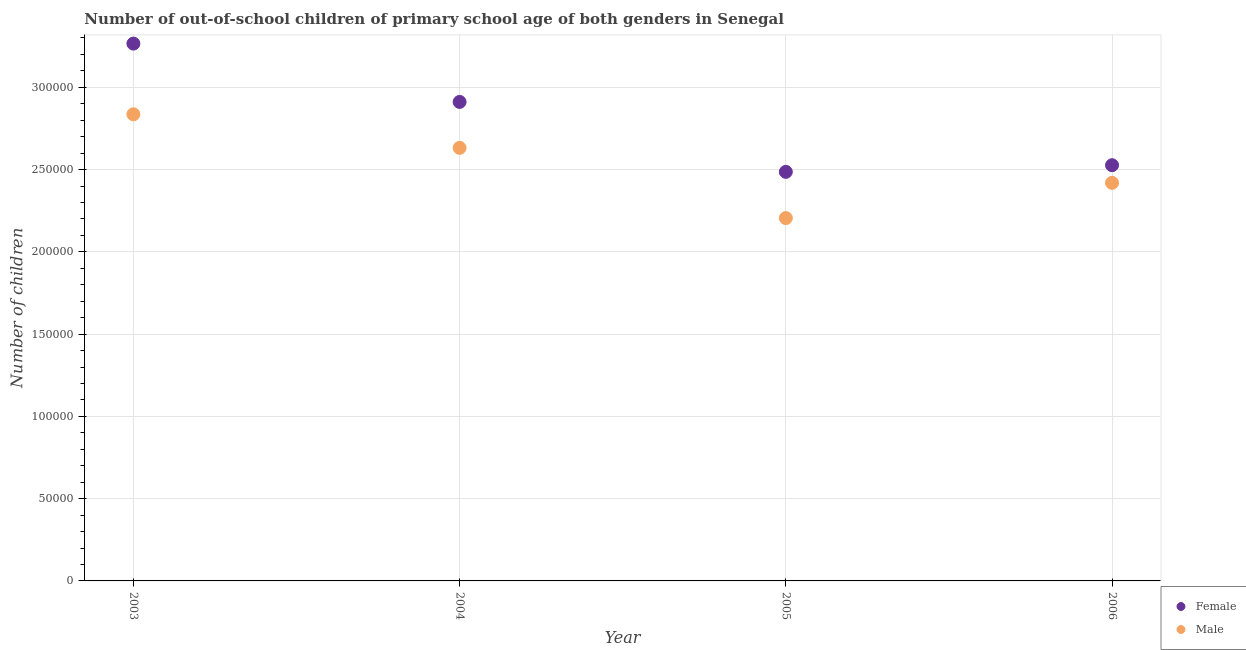What is the number of female out-of-school students in 2006?
Keep it short and to the point. 2.53e+05. Across all years, what is the maximum number of male out-of-school students?
Ensure brevity in your answer.  2.84e+05. Across all years, what is the minimum number of male out-of-school students?
Keep it short and to the point. 2.21e+05. In which year was the number of male out-of-school students minimum?
Your answer should be compact. 2005. What is the total number of female out-of-school students in the graph?
Your answer should be very brief. 1.12e+06. What is the difference between the number of male out-of-school students in 2003 and that in 2005?
Ensure brevity in your answer.  6.31e+04. What is the difference between the number of male out-of-school students in 2006 and the number of female out-of-school students in 2004?
Give a very brief answer. -4.92e+04. What is the average number of male out-of-school students per year?
Offer a terse response. 2.52e+05. In the year 2006, what is the difference between the number of female out-of-school students and number of male out-of-school students?
Your answer should be very brief. 1.07e+04. What is the ratio of the number of female out-of-school students in 2003 to that in 2005?
Give a very brief answer. 1.31. Is the number of male out-of-school students in 2005 less than that in 2006?
Your response must be concise. Yes. Is the difference between the number of male out-of-school students in 2003 and 2005 greater than the difference between the number of female out-of-school students in 2003 and 2005?
Ensure brevity in your answer.  No. What is the difference between the highest and the second highest number of male out-of-school students?
Offer a very short reply. 2.04e+04. What is the difference between the highest and the lowest number of female out-of-school students?
Provide a succinct answer. 7.79e+04. Does the number of female out-of-school students monotonically increase over the years?
Your answer should be compact. No. Is the number of male out-of-school students strictly greater than the number of female out-of-school students over the years?
Keep it short and to the point. No. How many years are there in the graph?
Keep it short and to the point. 4. Are the values on the major ticks of Y-axis written in scientific E-notation?
Ensure brevity in your answer.  No. Does the graph contain grids?
Your answer should be very brief. Yes. How many legend labels are there?
Keep it short and to the point. 2. What is the title of the graph?
Your answer should be very brief. Number of out-of-school children of primary school age of both genders in Senegal. What is the label or title of the X-axis?
Provide a short and direct response. Year. What is the label or title of the Y-axis?
Offer a very short reply. Number of children. What is the Number of children in Female in 2003?
Give a very brief answer. 3.27e+05. What is the Number of children in Male in 2003?
Your answer should be compact. 2.84e+05. What is the Number of children in Female in 2004?
Provide a succinct answer. 2.91e+05. What is the Number of children of Male in 2004?
Your response must be concise. 2.63e+05. What is the Number of children in Female in 2005?
Your response must be concise. 2.49e+05. What is the Number of children of Male in 2005?
Give a very brief answer. 2.21e+05. What is the Number of children in Female in 2006?
Provide a succinct answer. 2.53e+05. What is the Number of children in Male in 2006?
Offer a very short reply. 2.42e+05. Across all years, what is the maximum Number of children of Female?
Ensure brevity in your answer.  3.27e+05. Across all years, what is the maximum Number of children of Male?
Ensure brevity in your answer.  2.84e+05. Across all years, what is the minimum Number of children of Female?
Make the answer very short. 2.49e+05. Across all years, what is the minimum Number of children in Male?
Give a very brief answer. 2.21e+05. What is the total Number of children in Female in the graph?
Keep it short and to the point. 1.12e+06. What is the total Number of children in Male in the graph?
Make the answer very short. 1.01e+06. What is the difference between the Number of children of Female in 2003 and that in 2004?
Offer a very short reply. 3.54e+04. What is the difference between the Number of children of Male in 2003 and that in 2004?
Make the answer very short. 2.04e+04. What is the difference between the Number of children of Female in 2003 and that in 2005?
Make the answer very short. 7.79e+04. What is the difference between the Number of children of Male in 2003 and that in 2005?
Make the answer very short. 6.31e+04. What is the difference between the Number of children in Female in 2003 and that in 2006?
Give a very brief answer. 7.39e+04. What is the difference between the Number of children in Male in 2003 and that in 2006?
Your answer should be very brief. 4.17e+04. What is the difference between the Number of children in Female in 2004 and that in 2005?
Offer a terse response. 4.25e+04. What is the difference between the Number of children in Male in 2004 and that in 2005?
Your answer should be very brief. 4.27e+04. What is the difference between the Number of children in Female in 2004 and that in 2006?
Provide a short and direct response. 3.85e+04. What is the difference between the Number of children of Male in 2004 and that in 2006?
Your answer should be compact. 2.13e+04. What is the difference between the Number of children of Female in 2005 and that in 2006?
Offer a terse response. -4035. What is the difference between the Number of children of Male in 2005 and that in 2006?
Offer a terse response. -2.14e+04. What is the difference between the Number of children of Female in 2003 and the Number of children of Male in 2004?
Keep it short and to the point. 6.34e+04. What is the difference between the Number of children of Female in 2003 and the Number of children of Male in 2005?
Provide a short and direct response. 1.06e+05. What is the difference between the Number of children of Female in 2003 and the Number of children of Male in 2006?
Your response must be concise. 8.46e+04. What is the difference between the Number of children in Female in 2004 and the Number of children in Male in 2005?
Provide a succinct answer. 7.06e+04. What is the difference between the Number of children of Female in 2004 and the Number of children of Male in 2006?
Give a very brief answer. 4.92e+04. What is the difference between the Number of children in Female in 2005 and the Number of children in Male in 2006?
Provide a short and direct response. 6673. What is the average Number of children of Female per year?
Provide a short and direct response. 2.80e+05. What is the average Number of children of Male per year?
Offer a very short reply. 2.52e+05. In the year 2003, what is the difference between the Number of children of Female and Number of children of Male?
Offer a terse response. 4.30e+04. In the year 2004, what is the difference between the Number of children of Female and Number of children of Male?
Your answer should be very brief. 2.79e+04. In the year 2005, what is the difference between the Number of children of Female and Number of children of Male?
Offer a very short reply. 2.81e+04. In the year 2006, what is the difference between the Number of children in Female and Number of children in Male?
Provide a short and direct response. 1.07e+04. What is the ratio of the Number of children of Female in 2003 to that in 2004?
Provide a succinct answer. 1.12. What is the ratio of the Number of children in Male in 2003 to that in 2004?
Make the answer very short. 1.08. What is the ratio of the Number of children of Female in 2003 to that in 2005?
Your answer should be very brief. 1.31. What is the ratio of the Number of children of Male in 2003 to that in 2005?
Provide a succinct answer. 1.29. What is the ratio of the Number of children in Female in 2003 to that in 2006?
Provide a succinct answer. 1.29. What is the ratio of the Number of children in Male in 2003 to that in 2006?
Provide a succinct answer. 1.17. What is the ratio of the Number of children in Female in 2004 to that in 2005?
Keep it short and to the point. 1.17. What is the ratio of the Number of children in Male in 2004 to that in 2005?
Offer a very short reply. 1.19. What is the ratio of the Number of children in Female in 2004 to that in 2006?
Provide a short and direct response. 1.15. What is the ratio of the Number of children of Male in 2004 to that in 2006?
Your answer should be compact. 1.09. What is the ratio of the Number of children in Female in 2005 to that in 2006?
Ensure brevity in your answer.  0.98. What is the ratio of the Number of children in Male in 2005 to that in 2006?
Offer a very short reply. 0.91. What is the difference between the highest and the second highest Number of children in Female?
Ensure brevity in your answer.  3.54e+04. What is the difference between the highest and the second highest Number of children in Male?
Keep it short and to the point. 2.04e+04. What is the difference between the highest and the lowest Number of children in Female?
Make the answer very short. 7.79e+04. What is the difference between the highest and the lowest Number of children of Male?
Make the answer very short. 6.31e+04. 